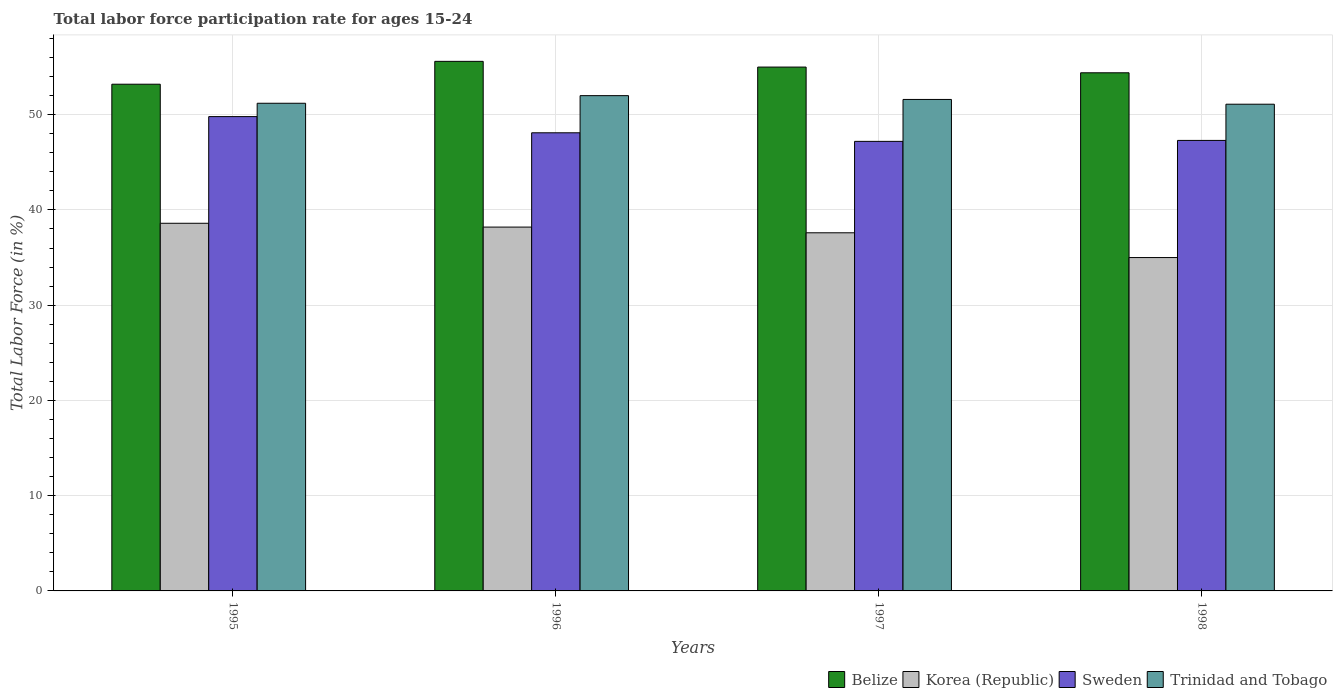How many groups of bars are there?
Your answer should be compact. 4. Are the number of bars per tick equal to the number of legend labels?
Your answer should be very brief. Yes. Are the number of bars on each tick of the X-axis equal?
Offer a terse response. Yes. How many bars are there on the 3rd tick from the left?
Your answer should be very brief. 4. How many bars are there on the 2nd tick from the right?
Ensure brevity in your answer.  4. What is the labor force participation rate in Belize in 1998?
Your response must be concise. 54.4. Across all years, what is the maximum labor force participation rate in Sweden?
Provide a succinct answer. 49.8. Across all years, what is the minimum labor force participation rate in Korea (Republic)?
Provide a succinct answer. 35. In which year was the labor force participation rate in Korea (Republic) maximum?
Your response must be concise. 1995. What is the total labor force participation rate in Korea (Republic) in the graph?
Keep it short and to the point. 149.4. What is the difference between the labor force participation rate in Trinidad and Tobago in 1995 and that in 1996?
Make the answer very short. -0.8. What is the difference between the labor force participation rate in Trinidad and Tobago in 1998 and the labor force participation rate in Belize in 1995?
Provide a short and direct response. -2.1. What is the average labor force participation rate in Belize per year?
Provide a succinct answer. 54.55. In the year 1997, what is the difference between the labor force participation rate in Trinidad and Tobago and labor force participation rate in Belize?
Provide a succinct answer. -3.4. In how many years, is the labor force participation rate in Belize greater than 28 %?
Keep it short and to the point. 4. What is the ratio of the labor force participation rate in Belize in 1995 to that in 1996?
Make the answer very short. 0.96. What is the difference between the highest and the second highest labor force participation rate in Belize?
Make the answer very short. 0.6. What is the difference between the highest and the lowest labor force participation rate in Korea (Republic)?
Your answer should be very brief. 3.6. In how many years, is the labor force participation rate in Trinidad and Tobago greater than the average labor force participation rate in Trinidad and Tobago taken over all years?
Give a very brief answer. 2. Is the sum of the labor force participation rate in Sweden in 1996 and 1997 greater than the maximum labor force participation rate in Trinidad and Tobago across all years?
Provide a succinct answer. Yes. What does the 1st bar from the left in 1997 represents?
Offer a very short reply. Belize. Are all the bars in the graph horizontal?
Offer a very short reply. No. How many years are there in the graph?
Your answer should be compact. 4. Where does the legend appear in the graph?
Give a very brief answer. Bottom right. How are the legend labels stacked?
Your answer should be compact. Horizontal. What is the title of the graph?
Your response must be concise. Total labor force participation rate for ages 15-24. What is the label or title of the X-axis?
Give a very brief answer. Years. What is the Total Labor Force (in %) in Belize in 1995?
Give a very brief answer. 53.2. What is the Total Labor Force (in %) in Korea (Republic) in 1995?
Your answer should be very brief. 38.6. What is the Total Labor Force (in %) of Sweden in 1995?
Provide a short and direct response. 49.8. What is the Total Labor Force (in %) of Trinidad and Tobago in 1995?
Give a very brief answer. 51.2. What is the Total Labor Force (in %) of Belize in 1996?
Ensure brevity in your answer.  55.6. What is the Total Labor Force (in %) of Korea (Republic) in 1996?
Make the answer very short. 38.2. What is the Total Labor Force (in %) of Sweden in 1996?
Offer a terse response. 48.1. What is the Total Labor Force (in %) of Korea (Republic) in 1997?
Ensure brevity in your answer.  37.6. What is the Total Labor Force (in %) in Sweden in 1997?
Give a very brief answer. 47.2. What is the Total Labor Force (in %) in Trinidad and Tobago in 1997?
Offer a terse response. 51.6. What is the Total Labor Force (in %) of Belize in 1998?
Ensure brevity in your answer.  54.4. What is the Total Labor Force (in %) of Sweden in 1998?
Give a very brief answer. 47.3. What is the Total Labor Force (in %) in Trinidad and Tobago in 1998?
Offer a terse response. 51.1. Across all years, what is the maximum Total Labor Force (in %) of Belize?
Make the answer very short. 55.6. Across all years, what is the maximum Total Labor Force (in %) of Korea (Republic)?
Your answer should be very brief. 38.6. Across all years, what is the maximum Total Labor Force (in %) in Sweden?
Your answer should be compact. 49.8. Across all years, what is the minimum Total Labor Force (in %) of Belize?
Keep it short and to the point. 53.2. Across all years, what is the minimum Total Labor Force (in %) of Korea (Republic)?
Provide a short and direct response. 35. Across all years, what is the minimum Total Labor Force (in %) of Sweden?
Provide a short and direct response. 47.2. Across all years, what is the minimum Total Labor Force (in %) of Trinidad and Tobago?
Your answer should be very brief. 51.1. What is the total Total Labor Force (in %) in Belize in the graph?
Ensure brevity in your answer.  218.2. What is the total Total Labor Force (in %) of Korea (Republic) in the graph?
Make the answer very short. 149.4. What is the total Total Labor Force (in %) of Sweden in the graph?
Your answer should be compact. 192.4. What is the total Total Labor Force (in %) of Trinidad and Tobago in the graph?
Keep it short and to the point. 205.9. What is the difference between the Total Labor Force (in %) of Sweden in 1995 and that in 1997?
Provide a short and direct response. 2.6. What is the difference between the Total Labor Force (in %) of Korea (Republic) in 1995 and that in 1998?
Your answer should be compact. 3.6. What is the difference between the Total Labor Force (in %) in Sweden in 1995 and that in 1998?
Provide a succinct answer. 2.5. What is the difference between the Total Labor Force (in %) of Trinidad and Tobago in 1996 and that in 1997?
Your answer should be compact. 0.4. What is the difference between the Total Labor Force (in %) in Belize in 1996 and that in 1998?
Ensure brevity in your answer.  1.2. What is the difference between the Total Labor Force (in %) of Sweden in 1996 and that in 1998?
Provide a succinct answer. 0.8. What is the difference between the Total Labor Force (in %) in Trinidad and Tobago in 1996 and that in 1998?
Make the answer very short. 0.9. What is the difference between the Total Labor Force (in %) in Sweden in 1997 and that in 1998?
Provide a short and direct response. -0.1. What is the difference between the Total Labor Force (in %) of Belize in 1995 and the Total Labor Force (in %) of Sweden in 1997?
Ensure brevity in your answer.  6. What is the difference between the Total Labor Force (in %) in Belize in 1995 and the Total Labor Force (in %) in Trinidad and Tobago in 1997?
Ensure brevity in your answer.  1.6. What is the difference between the Total Labor Force (in %) of Sweden in 1995 and the Total Labor Force (in %) of Trinidad and Tobago in 1997?
Keep it short and to the point. -1.8. What is the difference between the Total Labor Force (in %) of Belize in 1995 and the Total Labor Force (in %) of Sweden in 1998?
Your answer should be compact. 5.9. What is the difference between the Total Labor Force (in %) of Korea (Republic) in 1995 and the Total Labor Force (in %) of Trinidad and Tobago in 1998?
Ensure brevity in your answer.  -12.5. What is the difference between the Total Labor Force (in %) in Belize in 1996 and the Total Labor Force (in %) in Korea (Republic) in 1997?
Offer a terse response. 18. What is the difference between the Total Labor Force (in %) of Belize in 1996 and the Total Labor Force (in %) of Sweden in 1997?
Provide a short and direct response. 8.4. What is the difference between the Total Labor Force (in %) of Belize in 1996 and the Total Labor Force (in %) of Trinidad and Tobago in 1997?
Your answer should be compact. 4. What is the difference between the Total Labor Force (in %) in Korea (Republic) in 1996 and the Total Labor Force (in %) in Sweden in 1997?
Offer a terse response. -9. What is the difference between the Total Labor Force (in %) in Korea (Republic) in 1996 and the Total Labor Force (in %) in Trinidad and Tobago in 1997?
Offer a very short reply. -13.4. What is the difference between the Total Labor Force (in %) of Belize in 1996 and the Total Labor Force (in %) of Korea (Republic) in 1998?
Offer a terse response. 20.6. What is the difference between the Total Labor Force (in %) of Belize in 1996 and the Total Labor Force (in %) of Trinidad and Tobago in 1998?
Make the answer very short. 4.5. What is the difference between the Total Labor Force (in %) in Korea (Republic) in 1996 and the Total Labor Force (in %) in Sweden in 1998?
Give a very brief answer. -9.1. What is the difference between the Total Labor Force (in %) of Sweden in 1996 and the Total Labor Force (in %) of Trinidad and Tobago in 1998?
Your response must be concise. -3. What is the difference between the Total Labor Force (in %) of Belize in 1997 and the Total Labor Force (in %) of Korea (Republic) in 1998?
Your answer should be very brief. 20. What is the difference between the Total Labor Force (in %) in Belize in 1997 and the Total Labor Force (in %) in Sweden in 1998?
Offer a very short reply. 7.7. What is the difference between the Total Labor Force (in %) of Sweden in 1997 and the Total Labor Force (in %) of Trinidad and Tobago in 1998?
Your response must be concise. -3.9. What is the average Total Labor Force (in %) of Belize per year?
Give a very brief answer. 54.55. What is the average Total Labor Force (in %) of Korea (Republic) per year?
Give a very brief answer. 37.35. What is the average Total Labor Force (in %) of Sweden per year?
Offer a terse response. 48.1. What is the average Total Labor Force (in %) in Trinidad and Tobago per year?
Provide a succinct answer. 51.48. In the year 1995, what is the difference between the Total Labor Force (in %) in Belize and Total Labor Force (in %) in Sweden?
Your response must be concise. 3.4. In the year 1995, what is the difference between the Total Labor Force (in %) in Korea (Republic) and Total Labor Force (in %) in Sweden?
Your answer should be very brief. -11.2. In the year 1996, what is the difference between the Total Labor Force (in %) in Belize and Total Labor Force (in %) in Korea (Republic)?
Ensure brevity in your answer.  17.4. In the year 1996, what is the difference between the Total Labor Force (in %) of Belize and Total Labor Force (in %) of Sweden?
Your answer should be very brief. 7.5. In the year 1996, what is the difference between the Total Labor Force (in %) in Korea (Republic) and Total Labor Force (in %) in Trinidad and Tobago?
Give a very brief answer. -13.8. In the year 1997, what is the difference between the Total Labor Force (in %) in Belize and Total Labor Force (in %) in Korea (Republic)?
Your response must be concise. 17.4. In the year 1997, what is the difference between the Total Labor Force (in %) in Korea (Republic) and Total Labor Force (in %) in Sweden?
Provide a short and direct response. -9.6. In the year 1997, what is the difference between the Total Labor Force (in %) in Korea (Republic) and Total Labor Force (in %) in Trinidad and Tobago?
Offer a very short reply. -14. In the year 1997, what is the difference between the Total Labor Force (in %) of Sweden and Total Labor Force (in %) of Trinidad and Tobago?
Provide a succinct answer. -4.4. In the year 1998, what is the difference between the Total Labor Force (in %) in Korea (Republic) and Total Labor Force (in %) in Trinidad and Tobago?
Your answer should be very brief. -16.1. In the year 1998, what is the difference between the Total Labor Force (in %) of Sweden and Total Labor Force (in %) of Trinidad and Tobago?
Provide a short and direct response. -3.8. What is the ratio of the Total Labor Force (in %) in Belize in 1995 to that in 1996?
Your response must be concise. 0.96. What is the ratio of the Total Labor Force (in %) in Korea (Republic) in 1995 to that in 1996?
Make the answer very short. 1.01. What is the ratio of the Total Labor Force (in %) in Sweden in 1995 to that in 1996?
Your response must be concise. 1.04. What is the ratio of the Total Labor Force (in %) of Trinidad and Tobago in 1995 to that in 1996?
Your response must be concise. 0.98. What is the ratio of the Total Labor Force (in %) in Belize in 1995 to that in 1997?
Give a very brief answer. 0.97. What is the ratio of the Total Labor Force (in %) in Korea (Republic) in 1995 to that in 1997?
Give a very brief answer. 1.03. What is the ratio of the Total Labor Force (in %) of Sweden in 1995 to that in 1997?
Provide a succinct answer. 1.06. What is the ratio of the Total Labor Force (in %) of Belize in 1995 to that in 1998?
Offer a terse response. 0.98. What is the ratio of the Total Labor Force (in %) of Korea (Republic) in 1995 to that in 1998?
Ensure brevity in your answer.  1.1. What is the ratio of the Total Labor Force (in %) of Sweden in 1995 to that in 1998?
Give a very brief answer. 1.05. What is the ratio of the Total Labor Force (in %) of Trinidad and Tobago in 1995 to that in 1998?
Make the answer very short. 1. What is the ratio of the Total Labor Force (in %) in Belize in 1996 to that in 1997?
Your response must be concise. 1.01. What is the ratio of the Total Labor Force (in %) of Korea (Republic) in 1996 to that in 1997?
Make the answer very short. 1.02. What is the ratio of the Total Labor Force (in %) of Sweden in 1996 to that in 1997?
Your answer should be compact. 1.02. What is the ratio of the Total Labor Force (in %) in Trinidad and Tobago in 1996 to that in 1997?
Give a very brief answer. 1.01. What is the ratio of the Total Labor Force (in %) of Belize in 1996 to that in 1998?
Provide a short and direct response. 1.02. What is the ratio of the Total Labor Force (in %) in Korea (Republic) in 1996 to that in 1998?
Ensure brevity in your answer.  1.09. What is the ratio of the Total Labor Force (in %) in Sweden in 1996 to that in 1998?
Give a very brief answer. 1.02. What is the ratio of the Total Labor Force (in %) of Trinidad and Tobago in 1996 to that in 1998?
Offer a terse response. 1.02. What is the ratio of the Total Labor Force (in %) in Korea (Republic) in 1997 to that in 1998?
Your answer should be very brief. 1.07. What is the ratio of the Total Labor Force (in %) in Trinidad and Tobago in 1997 to that in 1998?
Offer a very short reply. 1.01. What is the difference between the highest and the second highest Total Labor Force (in %) of Belize?
Provide a succinct answer. 0.6. What is the difference between the highest and the second highest Total Labor Force (in %) in Korea (Republic)?
Offer a terse response. 0.4. What is the difference between the highest and the lowest Total Labor Force (in %) of Belize?
Your answer should be compact. 2.4. What is the difference between the highest and the lowest Total Labor Force (in %) in Korea (Republic)?
Make the answer very short. 3.6. What is the difference between the highest and the lowest Total Labor Force (in %) in Sweden?
Your response must be concise. 2.6. 